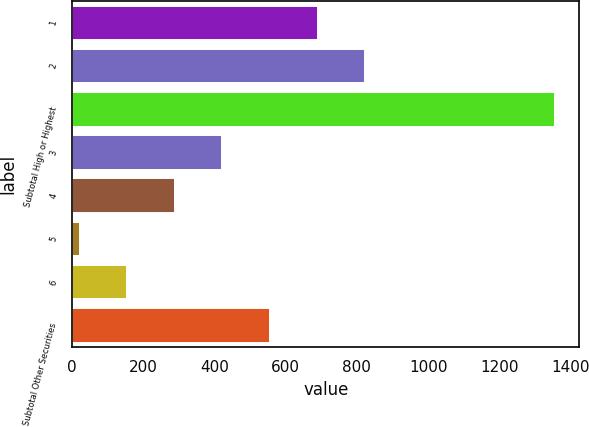<chart> <loc_0><loc_0><loc_500><loc_500><bar_chart><fcel>1<fcel>2<fcel>Subtotal High or Highest<fcel>3<fcel>4<fcel>5<fcel>6<fcel>Subtotal Other Securities<nl><fcel>689.5<fcel>823<fcel>1357<fcel>422.5<fcel>289<fcel>22<fcel>155.5<fcel>556<nl></chart> 